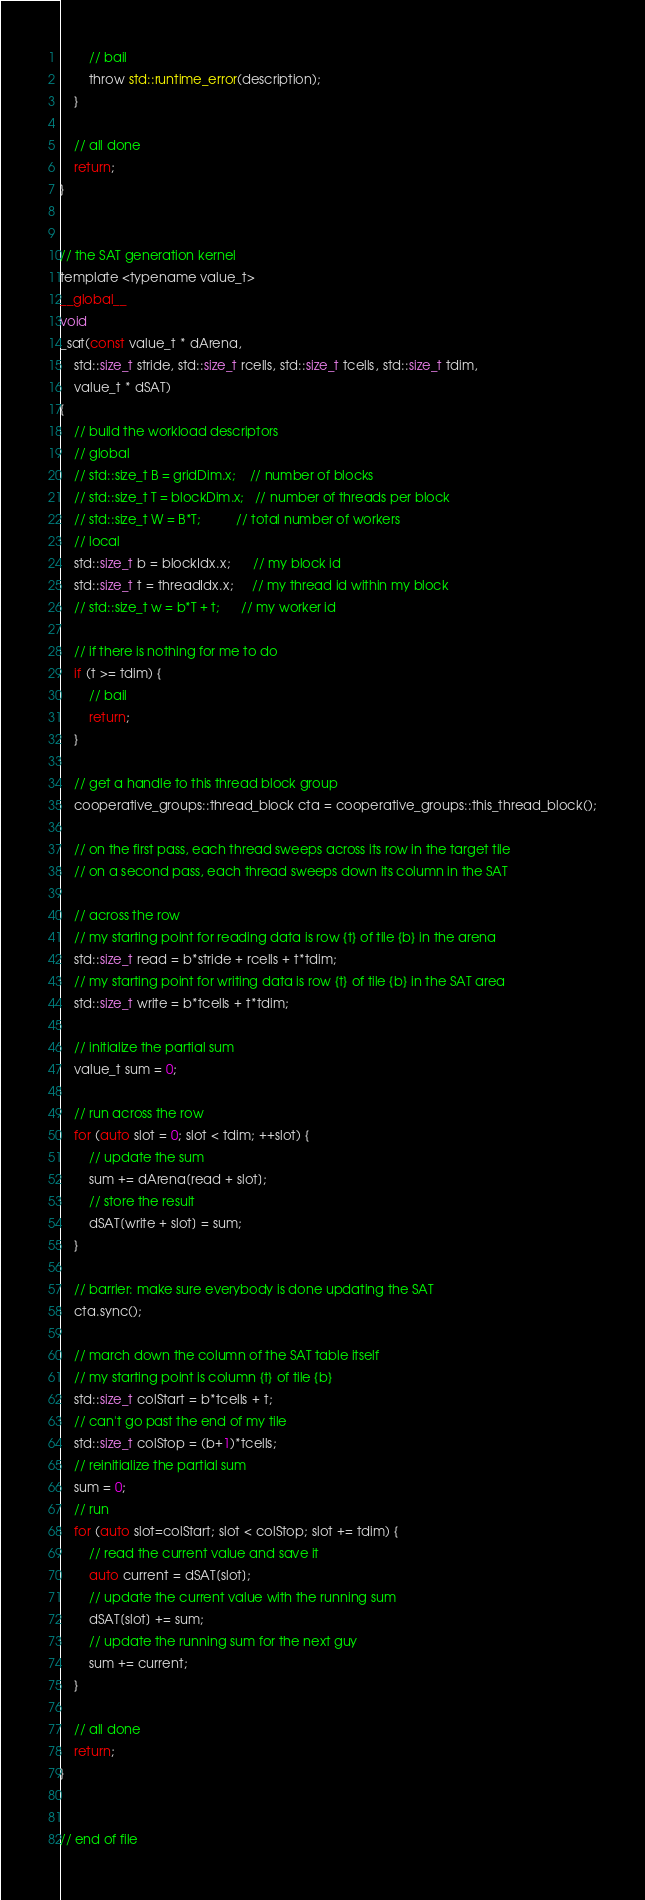Convert code to text. <code><loc_0><loc_0><loc_500><loc_500><_Cuda_>        // bail
        throw std::runtime_error(description);
    }

    // all done
    return;
}


// the SAT generation kernel
template <typename value_t>
__global__
void
_sat(const value_t * dArena,
    std::size_t stride, std::size_t rcells, std::size_t tcells, std::size_t tdim,
    value_t * dSAT)
{
    // build the workload descriptors
    // global
    // std::size_t B = gridDim.x;    // number of blocks
    // std::size_t T = blockDim.x;   // number of threads per block
    // std::size_t W = B*T;          // total number of workers
    // local
    std::size_t b = blockIdx.x;      // my block id
    std::size_t t = threadIdx.x;     // my thread id within my block
    // std::size_t w = b*T + t;      // my worker id

    // if there is nothing for me to do
    if (t >= tdim) {
        // bail
        return;
    }

    // get a handle to this thread block group
    cooperative_groups::thread_block cta = cooperative_groups::this_thread_block();

    // on the first pass, each thread sweeps across its row in the target tile
    // on a second pass, each thread sweeps down its column in the SAT

    // across the row
    // my starting point for reading data is row {t} of tile {b} in the arena
    std::size_t read = b*stride + rcells + t*tdim;
    // my starting point for writing data is row {t} of tile {b} in the SAT area
    std::size_t write = b*tcells + t*tdim;

    // initialize the partial sum
    value_t sum = 0;

    // run across the row
    for (auto slot = 0; slot < tdim; ++slot) {
        // update the sum
        sum += dArena[read + slot];
        // store the result
        dSAT[write + slot] = sum;
    }

    // barrier: make sure everybody is done updating the SAT
    cta.sync();

    // march down the column of the SAT table itself
    // my starting point is column {t} of tile {b}
    std::size_t colStart = b*tcells + t;
    // can't go past the end of my tile
    std::size_t colStop = (b+1)*tcells;
    // reinitialize the partial sum
    sum = 0;
    // run
    for (auto slot=colStart; slot < colStop; slot += tdim) {
        // read the current value and save it
        auto current = dSAT[slot];
        // update the current value with the running sum
        dSAT[slot] += sum;
        // update the running sum for the next guy
        sum += current;
    }

    // all done
    return;
}


// end of file
</code> 